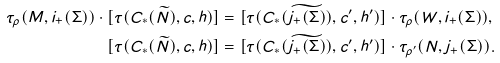<formula> <loc_0><loc_0><loc_500><loc_500>\tau _ { \rho } ( M , i _ { + } ( \Sigma ) ) \cdot [ \tau ( C _ { * } ( \widetilde { N } ) , c , h ) ] & = [ \tau ( C _ { * } ( \widetilde { j _ { + } ( \Sigma ) } ) , c ^ { \prime } , h ^ { \prime } ) ] \cdot \tau _ { \rho } ( W , i _ { + } ( \Sigma ) ) , \\ [ \tau ( C _ { * } ( \widetilde { N } ) , c , h ) ] & = [ \tau ( C _ { * } ( \widetilde { j _ { + } ( \Sigma ) } ) , c ^ { \prime } , h ^ { \prime } ) ] \cdot \tau _ { \rho ^ { \prime } } ( N , j _ { + } ( \Sigma ) ) .</formula> 